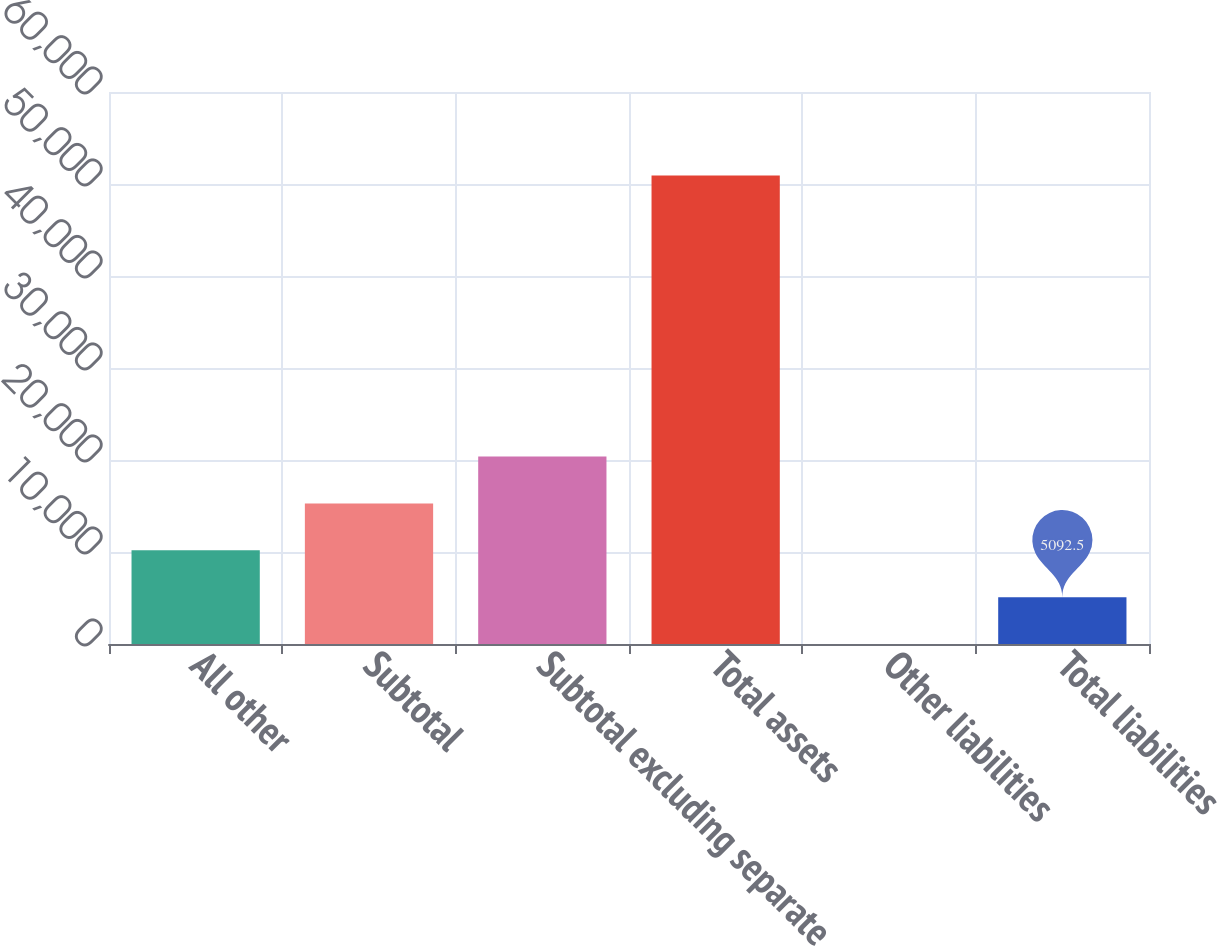Convert chart to OTSL. <chart><loc_0><loc_0><loc_500><loc_500><bar_chart><fcel>All other<fcel>Subtotal<fcel>Subtotal excluding separate<fcel>Total assets<fcel>Other liabilities<fcel>Total liabilities<nl><fcel>10184<fcel>15275.5<fcel>20367<fcel>50916<fcel>1<fcel>5092.5<nl></chart> 